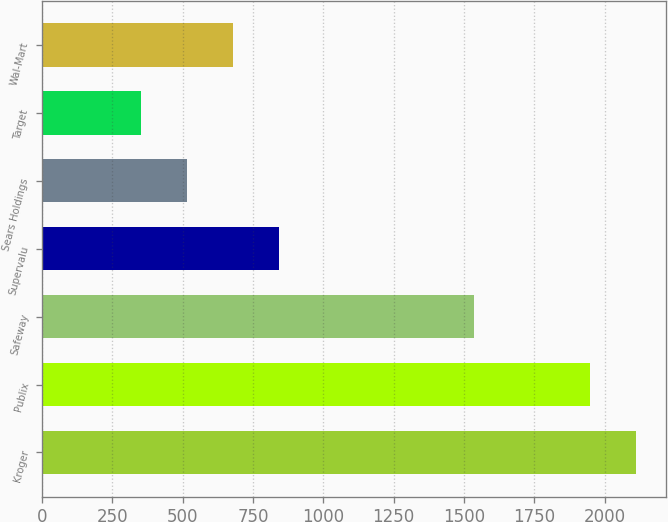<chart> <loc_0><loc_0><loc_500><loc_500><bar_chart><fcel>Kroger<fcel>Publix<fcel>Safeway<fcel>Supervalu<fcel>Sears Holdings<fcel>Target<fcel>Wal-Mart<nl><fcel>2111.7<fcel>1948<fcel>1535<fcel>841.1<fcel>513.7<fcel>350<fcel>677.4<nl></chart> 